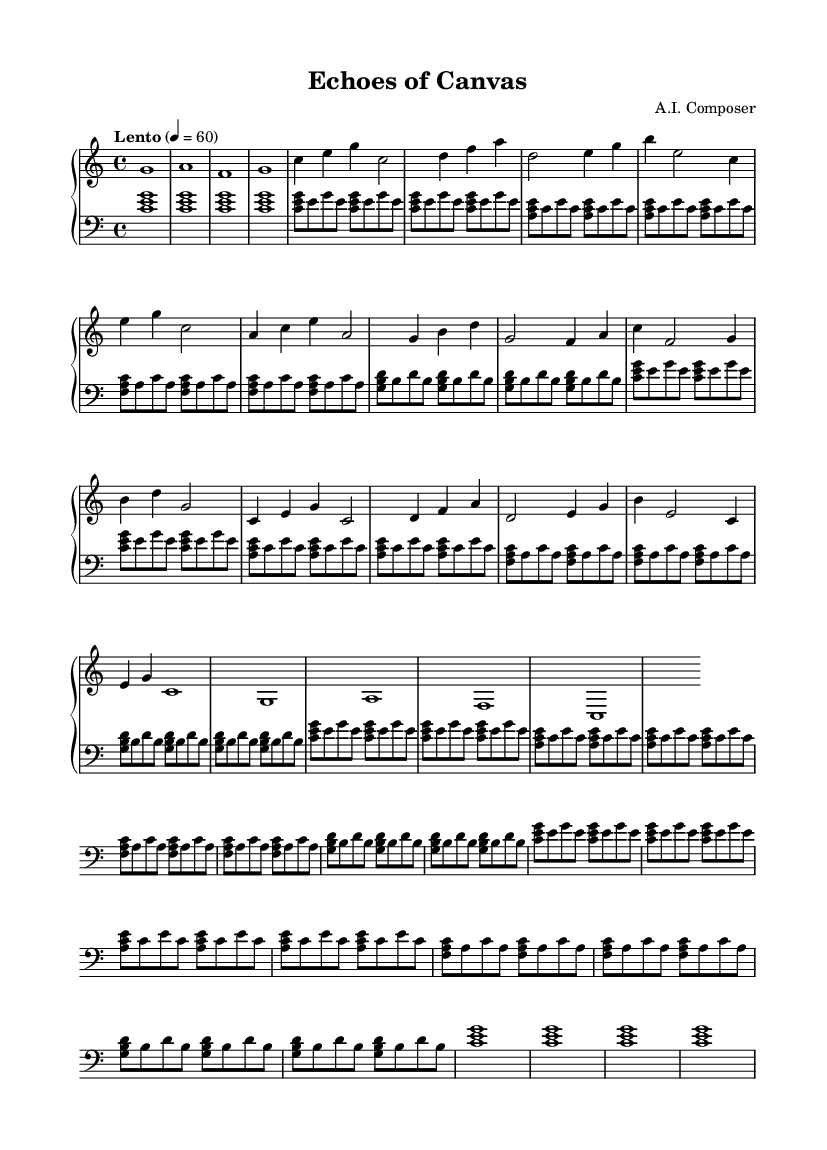What is the key signature of this music? The key signature is C major, which has no sharps or flats.
Answer: C major What is the time signature of this music? The time signature is indicated as 4/4, meaning there are four beats in each measure.
Answer: 4/4 What is the tempo of this piece? The tempo marking is "Lento" with a metronome marking of 60 beats per minute.
Answer: Lento, 60 How many measures are there in the A section? The A section consists of 4 measures, as all melodic phrases are contained within this section.
Answer: 4 What is the relationship between the A section and A' section? The A' section is a variation of the A section, both containing similar melodic content but with slight changes in dynamics and length.
Answer: Variation What melodic element is repeated in the left hand throughout the piece? The left hand features a repeated arpeggio pattern based on C major, contributing to the harmonic foundation of the music's minimalistic texture.
Answer: Arpeggios How does the B section contrast with the A section? The B section presents different melodies and harmonies, creating contrast through distinct chord progressions and rhythmic variations, enhancing the overall mood of the soundtrack.
Answer: Different melodies 